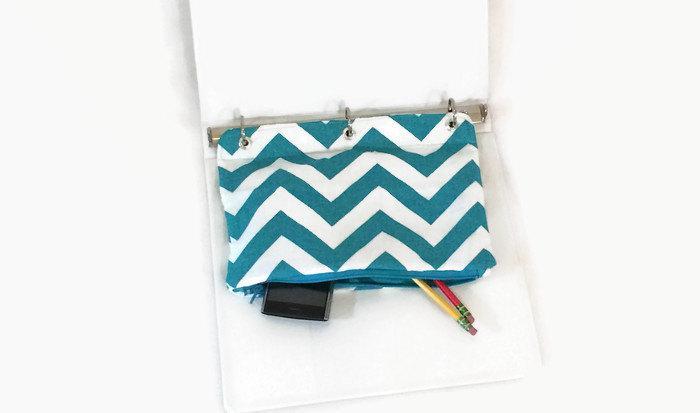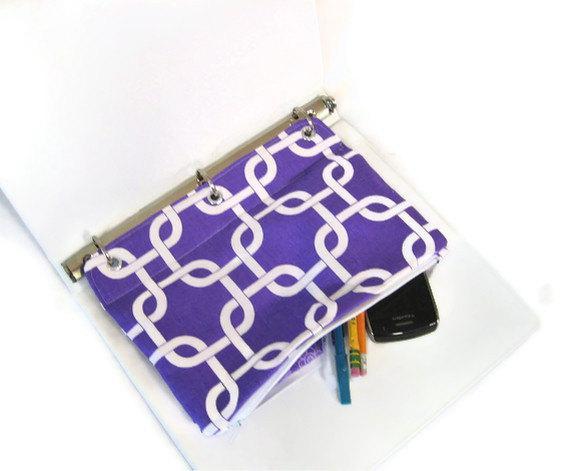The first image is the image on the left, the second image is the image on the right. For the images shown, is this caption "An image shows an open three-ring binder containing a pencil case, and the other image includes a pencil case that is not in a binder." true? Answer yes or no. No. The first image is the image on the left, the second image is the image on the right. Analyze the images presented: Is the assertion "writing utensils are sticking out of every single pencil case." valid? Answer yes or no. Yes. 